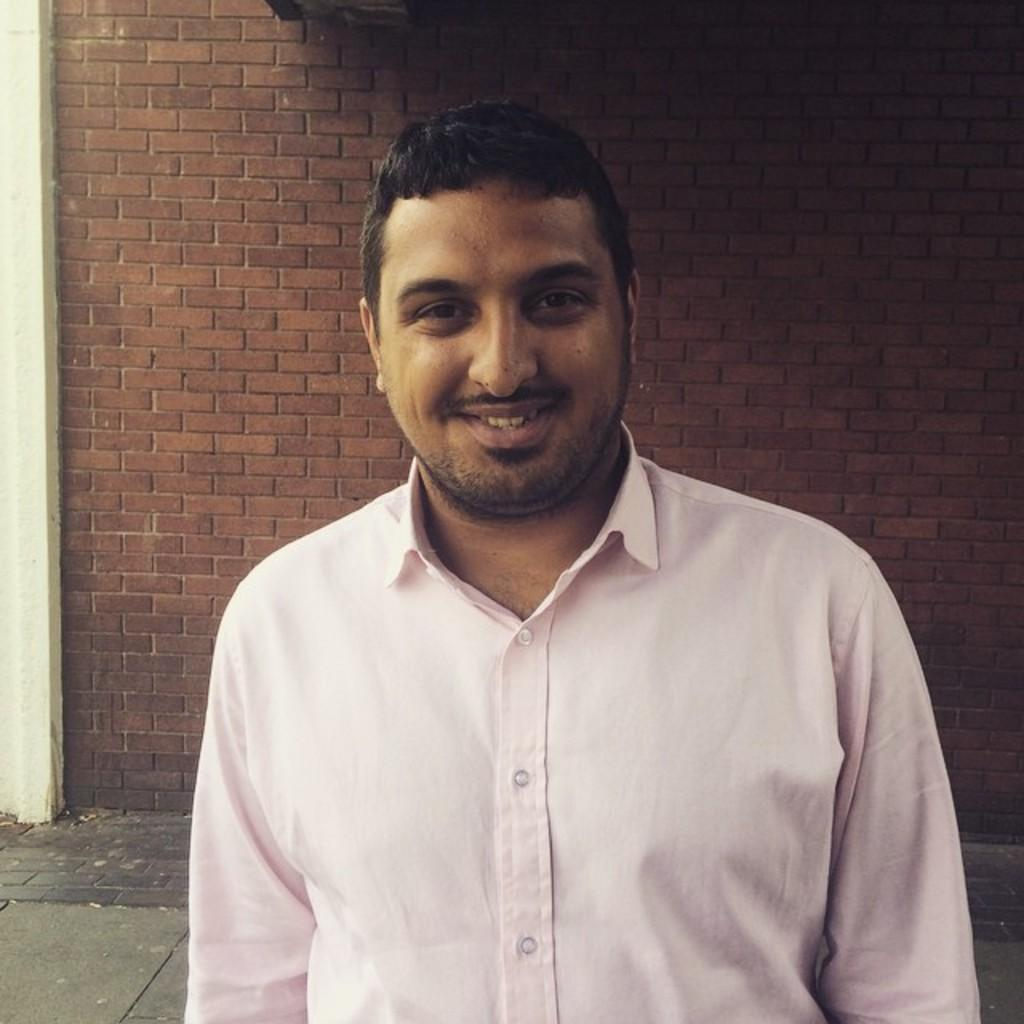What is the man in the image doing? The man is standing in the image. What is the man wearing? The man is wearing a pink shirt. What is the man's facial expression? The man is smiling. What can be seen in the background of the image? There is a brick wall and a walkway in the background of the image. What company does the man work for in the image? There is no information about the man's company in the image. How does the man look in the image? The man is described as smiling and wearing a pink shirt, but there is no specific information about his overall appearance. 